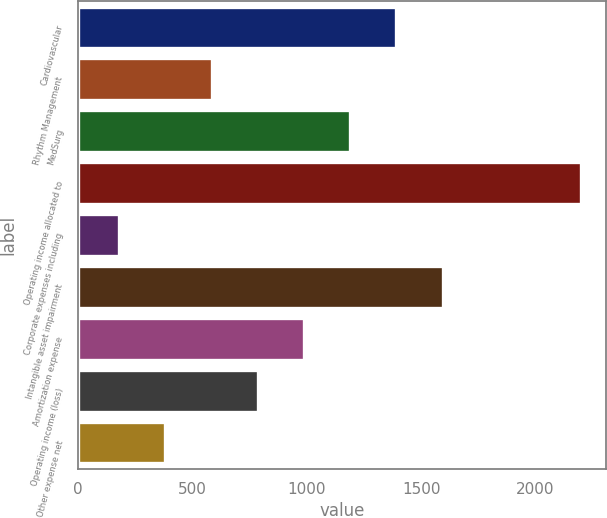Convert chart. <chart><loc_0><loc_0><loc_500><loc_500><bar_chart><fcel>Cardiovascular<fcel>Rhythm Management<fcel>MedSurg<fcel>Operating income allocated to<fcel>Corporate expenses including<fcel>Intangible asset impairment<fcel>Amortization expense<fcel>Operating income (loss)<fcel>Other expense net<nl><fcel>1391.6<fcel>583.2<fcel>1189.5<fcel>2200<fcel>179<fcel>1593.7<fcel>987.4<fcel>785.3<fcel>381.1<nl></chart> 